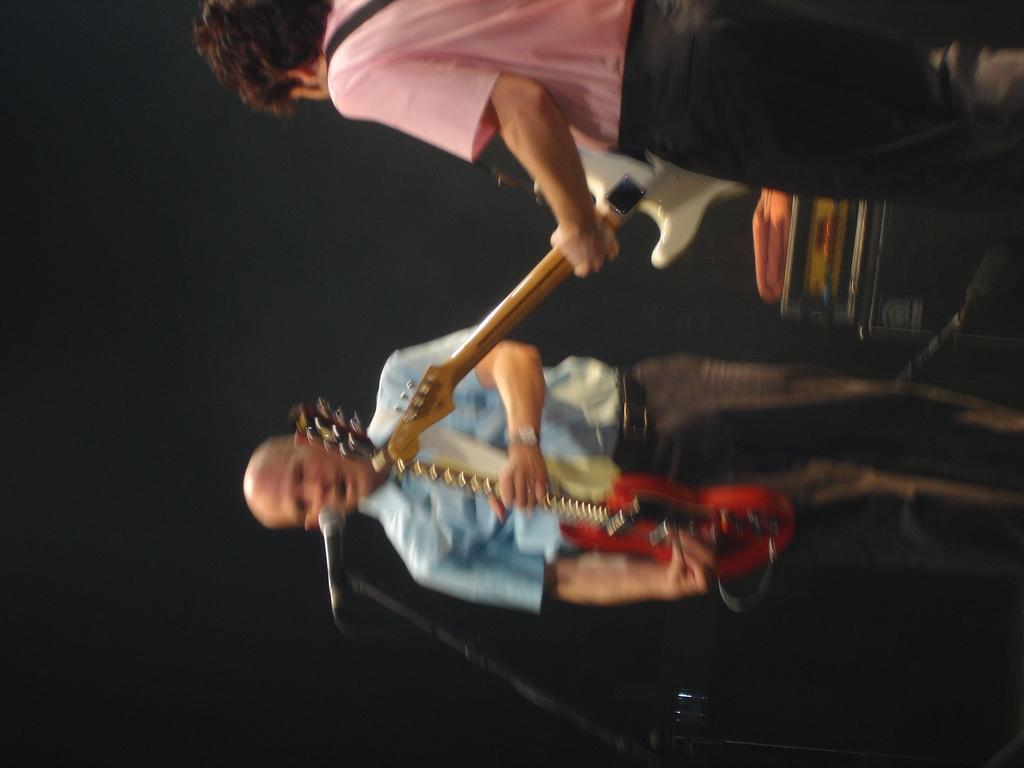How many people are in the image? There are two people in the image. What are the two people doing in the image? The two people are playing guitars. Can you identify any equipment related to music in the image? Yes, there is a microphone (mike) in the image. What type of fuel is being used by the car in the image? There is no car present in the image, so it is not possible to determine what type of fuel is being used. 